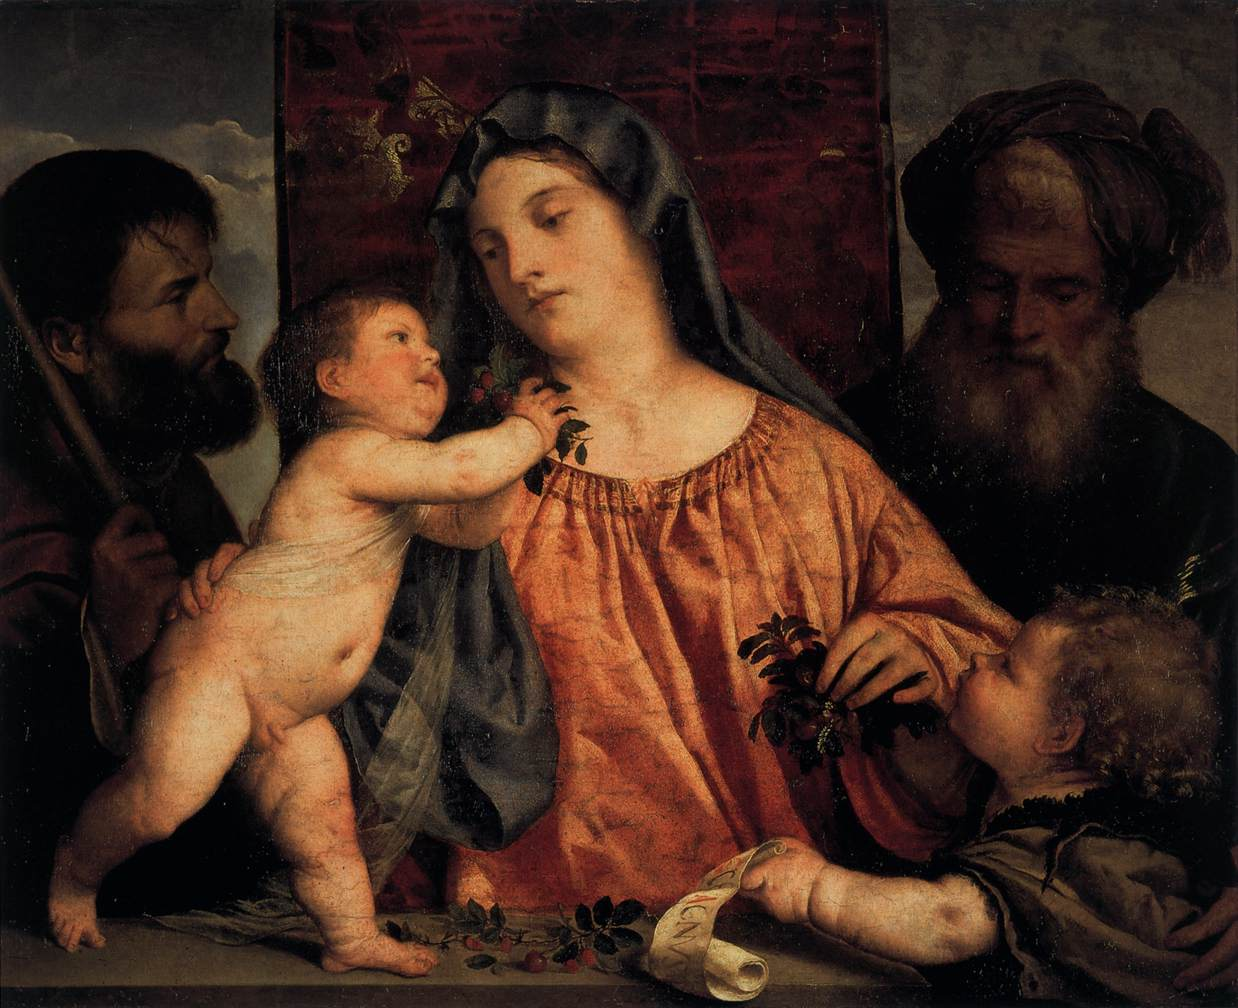Write a detailed description of the given image. This is an oil painting that depicts the Holy Family in the Mannerist style. The central figure is Mary, dressed in an orange dress and a blue veil, holding the infant Jesus. To her left is Joseph, and to her right is John the Baptist. The figures are elongated and posed dramatically, a characteristic of the Mannerist style. The background features a landscape under a dark sky, with a red curtain on the right side of the painting. The overall color scheme is predominantly dark, with the exception of Mary's vibrant attire. The painting is rich in detail and evokes a sense of solemnity and reverence. 